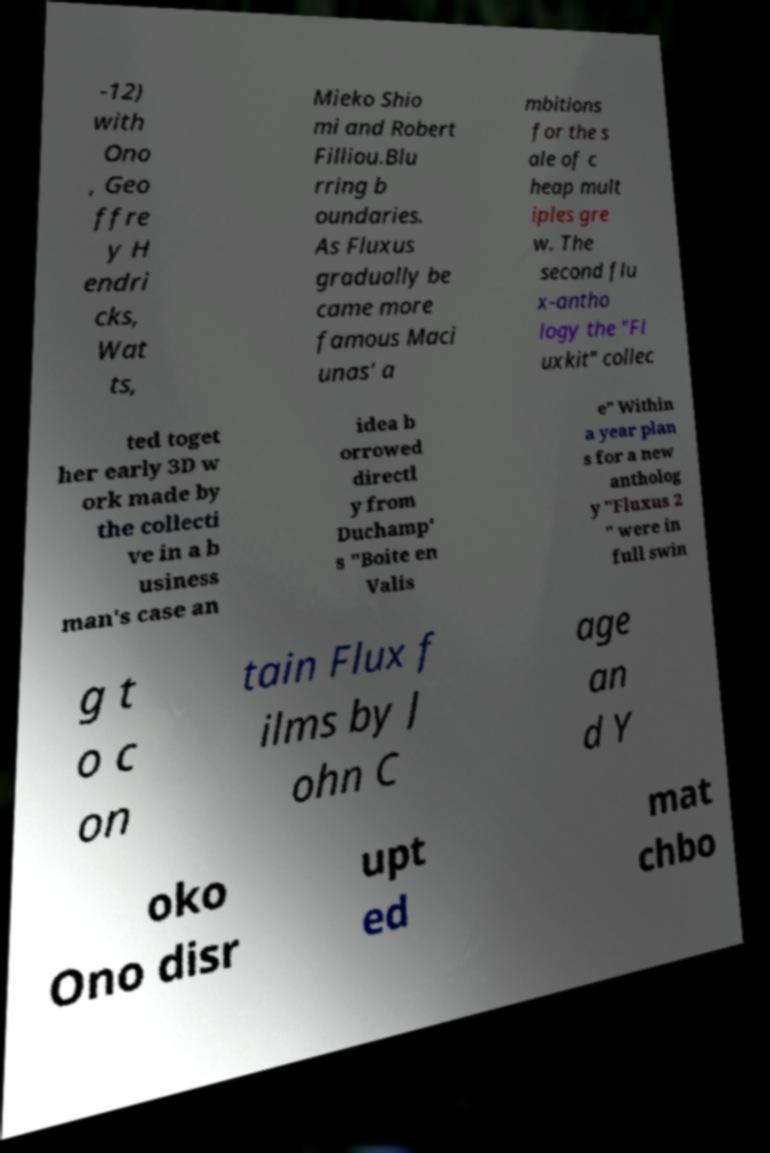Can you accurately transcribe the text from the provided image for me? -12) with Ono , Geo ffre y H endri cks, Wat ts, Mieko Shio mi and Robert Filliou.Blu rring b oundaries. As Fluxus gradually be came more famous Maci unas' a mbitions for the s ale of c heap mult iples gre w. The second flu x-antho logy the "Fl uxkit" collec ted toget her early 3D w ork made by the collecti ve in a b usiness man's case an idea b orrowed directl y from Duchamp' s "Boite en Valis e" Within a year plan s for a new antholog y "Fluxus 2 " were in full swin g t o c on tain Flux f ilms by J ohn C age an d Y oko Ono disr upt ed mat chbo 